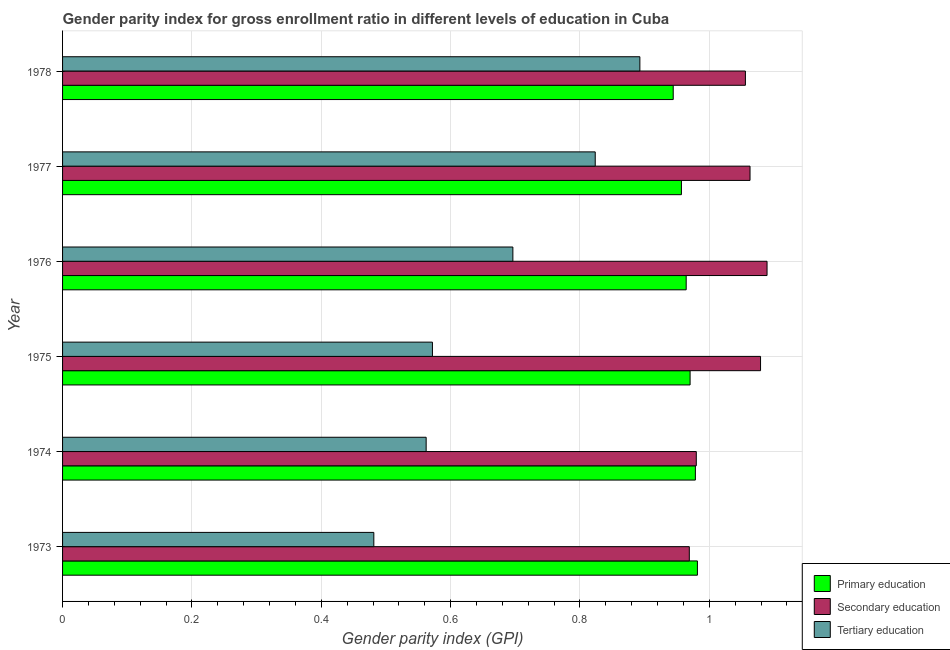How many different coloured bars are there?
Make the answer very short. 3. How many bars are there on the 2nd tick from the top?
Provide a succinct answer. 3. What is the label of the 1st group of bars from the top?
Give a very brief answer. 1978. In how many cases, is the number of bars for a given year not equal to the number of legend labels?
Keep it short and to the point. 0. What is the gender parity index in tertiary education in 1976?
Ensure brevity in your answer.  0.7. Across all years, what is the maximum gender parity index in primary education?
Provide a short and direct response. 0.98. Across all years, what is the minimum gender parity index in primary education?
Give a very brief answer. 0.94. In which year was the gender parity index in tertiary education maximum?
Your answer should be compact. 1978. In which year was the gender parity index in primary education minimum?
Provide a short and direct response. 1978. What is the total gender parity index in primary education in the graph?
Provide a succinct answer. 5.8. What is the difference between the gender parity index in primary education in 1973 and that in 1975?
Provide a succinct answer. 0.01. What is the difference between the gender parity index in primary education in 1976 and the gender parity index in tertiary education in 1973?
Your answer should be compact. 0.48. What is the average gender parity index in secondary education per year?
Offer a terse response. 1.04. In the year 1977, what is the difference between the gender parity index in secondary education and gender parity index in primary education?
Keep it short and to the point. 0.11. What is the ratio of the gender parity index in tertiary education in 1973 to that in 1975?
Ensure brevity in your answer.  0.84. Is the difference between the gender parity index in primary education in 1973 and 1974 greater than the difference between the gender parity index in secondary education in 1973 and 1974?
Ensure brevity in your answer.  Yes. What is the difference between the highest and the second highest gender parity index in primary education?
Offer a terse response. 0. What is the difference between the highest and the lowest gender parity index in secondary education?
Make the answer very short. 0.12. What does the 3rd bar from the bottom in 1975 represents?
Your answer should be very brief. Tertiary education. Is it the case that in every year, the sum of the gender parity index in primary education and gender parity index in secondary education is greater than the gender parity index in tertiary education?
Your answer should be very brief. Yes. Are all the bars in the graph horizontal?
Offer a very short reply. Yes. What is the difference between two consecutive major ticks on the X-axis?
Your response must be concise. 0.2. Are the values on the major ticks of X-axis written in scientific E-notation?
Ensure brevity in your answer.  No. Where does the legend appear in the graph?
Ensure brevity in your answer.  Bottom right. What is the title of the graph?
Ensure brevity in your answer.  Gender parity index for gross enrollment ratio in different levels of education in Cuba. Does "Nuclear sources" appear as one of the legend labels in the graph?
Make the answer very short. No. What is the label or title of the X-axis?
Give a very brief answer. Gender parity index (GPI). What is the Gender parity index (GPI) in Primary education in 1973?
Your answer should be very brief. 0.98. What is the Gender parity index (GPI) in Secondary education in 1973?
Provide a short and direct response. 0.97. What is the Gender parity index (GPI) in Tertiary education in 1973?
Your answer should be compact. 0.48. What is the Gender parity index (GPI) of Primary education in 1974?
Your answer should be very brief. 0.98. What is the Gender parity index (GPI) in Secondary education in 1974?
Keep it short and to the point. 0.98. What is the Gender parity index (GPI) of Tertiary education in 1974?
Make the answer very short. 0.56. What is the Gender parity index (GPI) of Primary education in 1975?
Ensure brevity in your answer.  0.97. What is the Gender parity index (GPI) of Secondary education in 1975?
Provide a succinct answer. 1.08. What is the Gender parity index (GPI) in Tertiary education in 1975?
Provide a succinct answer. 0.57. What is the Gender parity index (GPI) in Primary education in 1976?
Offer a terse response. 0.96. What is the Gender parity index (GPI) of Secondary education in 1976?
Provide a succinct answer. 1.09. What is the Gender parity index (GPI) of Tertiary education in 1976?
Give a very brief answer. 0.7. What is the Gender parity index (GPI) of Primary education in 1977?
Offer a very short reply. 0.96. What is the Gender parity index (GPI) in Secondary education in 1977?
Make the answer very short. 1.06. What is the Gender parity index (GPI) in Tertiary education in 1977?
Provide a succinct answer. 0.82. What is the Gender parity index (GPI) in Primary education in 1978?
Your answer should be compact. 0.94. What is the Gender parity index (GPI) of Secondary education in 1978?
Provide a succinct answer. 1.06. What is the Gender parity index (GPI) in Tertiary education in 1978?
Your response must be concise. 0.89. Across all years, what is the maximum Gender parity index (GPI) of Primary education?
Your answer should be compact. 0.98. Across all years, what is the maximum Gender parity index (GPI) in Secondary education?
Provide a succinct answer. 1.09. Across all years, what is the maximum Gender parity index (GPI) in Tertiary education?
Ensure brevity in your answer.  0.89. Across all years, what is the minimum Gender parity index (GPI) of Primary education?
Your answer should be very brief. 0.94. Across all years, what is the minimum Gender parity index (GPI) of Secondary education?
Provide a short and direct response. 0.97. Across all years, what is the minimum Gender parity index (GPI) in Tertiary education?
Ensure brevity in your answer.  0.48. What is the total Gender parity index (GPI) in Primary education in the graph?
Your answer should be compact. 5.8. What is the total Gender parity index (GPI) of Secondary education in the graph?
Keep it short and to the point. 6.24. What is the total Gender parity index (GPI) in Tertiary education in the graph?
Keep it short and to the point. 4.03. What is the difference between the Gender parity index (GPI) in Primary education in 1973 and that in 1974?
Ensure brevity in your answer.  0. What is the difference between the Gender parity index (GPI) in Secondary education in 1973 and that in 1974?
Your answer should be compact. -0.01. What is the difference between the Gender parity index (GPI) of Tertiary education in 1973 and that in 1974?
Make the answer very short. -0.08. What is the difference between the Gender parity index (GPI) of Primary education in 1973 and that in 1975?
Your answer should be very brief. 0.01. What is the difference between the Gender parity index (GPI) of Secondary education in 1973 and that in 1975?
Ensure brevity in your answer.  -0.11. What is the difference between the Gender parity index (GPI) of Tertiary education in 1973 and that in 1975?
Ensure brevity in your answer.  -0.09. What is the difference between the Gender parity index (GPI) in Primary education in 1973 and that in 1976?
Offer a terse response. 0.02. What is the difference between the Gender parity index (GPI) in Secondary education in 1973 and that in 1976?
Offer a terse response. -0.12. What is the difference between the Gender parity index (GPI) of Tertiary education in 1973 and that in 1976?
Your answer should be compact. -0.21. What is the difference between the Gender parity index (GPI) in Primary education in 1973 and that in 1977?
Keep it short and to the point. 0.02. What is the difference between the Gender parity index (GPI) of Secondary education in 1973 and that in 1977?
Ensure brevity in your answer.  -0.09. What is the difference between the Gender parity index (GPI) in Tertiary education in 1973 and that in 1977?
Provide a short and direct response. -0.34. What is the difference between the Gender parity index (GPI) of Primary education in 1973 and that in 1978?
Keep it short and to the point. 0.04. What is the difference between the Gender parity index (GPI) of Secondary education in 1973 and that in 1978?
Keep it short and to the point. -0.09. What is the difference between the Gender parity index (GPI) of Tertiary education in 1973 and that in 1978?
Provide a succinct answer. -0.41. What is the difference between the Gender parity index (GPI) in Primary education in 1974 and that in 1975?
Your answer should be compact. 0.01. What is the difference between the Gender parity index (GPI) of Secondary education in 1974 and that in 1975?
Make the answer very short. -0.1. What is the difference between the Gender parity index (GPI) in Tertiary education in 1974 and that in 1975?
Keep it short and to the point. -0.01. What is the difference between the Gender parity index (GPI) of Primary education in 1974 and that in 1976?
Your answer should be very brief. 0.01. What is the difference between the Gender parity index (GPI) in Secondary education in 1974 and that in 1976?
Offer a terse response. -0.11. What is the difference between the Gender parity index (GPI) in Tertiary education in 1974 and that in 1976?
Your response must be concise. -0.13. What is the difference between the Gender parity index (GPI) of Primary education in 1974 and that in 1977?
Give a very brief answer. 0.02. What is the difference between the Gender parity index (GPI) of Secondary education in 1974 and that in 1977?
Keep it short and to the point. -0.08. What is the difference between the Gender parity index (GPI) of Tertiary education in 1974 and that in 1977?
Offer a terse response. -0.26. What is the difference between the Gender parity index (GPI) in Primary education in 1974 and that in 1978?
Give a very brief answer. 0.03. What is the difference between the Gender parity index (GPI) of Secondary education in 1974 and that in 1978?
Provide a short and direct response. -0.08. What is the difference between the Gender parity index (GPI) of Tertiary education in 1974 and that in 1978?
Ensure brevity in your answer.  -0.33. What is the difference between the Gender parity index (GPI) in Primary education in 1975 and that in 1976?
Ensure brevity in your answer.  0.01. What is the difference between the Gender parity index (GPI) in Secondary education in 1975 and that in 1976?
Provide a succinct answer. -0.01. What is the difference between the Gender parity index (GPI) in Tertiary education in 1975 and that in 1976?
Your answer should be compact. -0.12. What is the difference between the Gender parity index (GPI) of Primary education in 1975 and that in 1977?
Provide a succinct answer. 0.01. What is the difference between the Gender parity index (GPI) of Secondary education in 1975 and that in 1977?
Provide a succinct answer. 0.02. What is the difference between the Gender parity index (GPI) of Tertiary education in 1975 and that in 1977?
Your answer should be very brief. -0.25. What is the difference between the Gender parity index (GPI) of Primary education in 1975 and that in 1978?
Your response must be concise. 0.03. What is the difference between the Gender parity index (GPI) of Secondary education in 1975 and that in 1978?
Your answer should be very brief. 0.02. What is the difference between the Gender parity index (GPI) in Tertiary education in 1975 and that in 1978?
Provide a short and direct response. -0.32. What is the difference between the Gender parity index (GPI) of Primary education in 1976 and that in 1977?
Provide a succinct answer. 0.01. What is the difference between the Gender parity index (GPI) of Secondary education in 1976 and that in 1977?
Give a very brief answer. 0.03. What is the difference between the Gender parity index (GPI) of Tertiary education in 1976 and that in 1977?
Make the answer very short. -0.13. What is the difference between the Gender parity index (GPI) of Primary education in 1976 and that in 1978?
Offer a terse response. 0.02. What is the difference between the Gender parity index (GPI) in Secondary education in 1976 and that in 1978?
Give a very brief answer. 0.03. What is the difference between the Gender parity index (GPI) of Tertiary education in 1976 and that in 1978?
Provide a succinct answer. -0.2. What is the difference between the Gender parity index (GPI) of Primary education in 1977 and that in 1978?
Provide a succinct answer. 0.01. What is the difference between the Gender parity index (GPI) in Secondary education in 1977 and that in 1978?
Ensure brevity in your answer.  0.01. What is the difference between the Gender parity index (GPI) in Tertiary education in 1977 and that in 1978?
Provide a short and direct response. -0.07. What is the difference between the Gender parity index (GPI) of Primary education in 1973 and the Gender parity index (GPI) of Secondary education in 1974?
Keep it short and to the point. 0. What is the difference between the Gender parity index (GPI) of Primary education in 1973 and the Gender parity index (GPI) of Tertiary education in 1974?
Keep it short and to the point. 0.42. What is the difference between the Gender parity index (GPI) in Secondary education in 1973 and the Gender parity index (GPI) in Tertiary education in 1974?
Your answer should be compact. 0.41. What is the difference between the Gender parity index (GPI) of Primary education in 1973 and the Gender parity index (GPI) of Secondary education in 1975?
Provide a succinct answer. -0.1. What is the difference between the Gender parity index (GPI) of Primary education in 1973 and the Gender parity index (GPI) of Tertiary education in 1975?
Your response must be concise. 0.41. What is the difference between the Gender parity index (GPI) in Secondary education in 1973 and the Gender parity index (GPI) in Tertiary education in 1975?
Ensure brevity in your answer.  0.4. What is the difference between the Gender parity index (GPI) in Primary education in 1973 and the Gender parity index (GPI) in Secondary education in 1976?
Keep it short and to the point. -0.11. What is the difference between the Gender parity index (GPI) of Primary education in 1973 and the Gender parity index (GPI) of Tertiary education in 1976?
Keep it short and to the point. 0.29. What is the difference between the Gender parity index (GPI) of Secondary education in 1973 and the Gender parity index (GPI) of Tertiary education in 1976?
Keep it short and to the point. 0.27. What is the difference between the Gender parity index (GPI) in Primary education in 1973 and the Gender parity index (GPI) in Secondary education in 1977?
Your response must be concise. -0.08. What is the difference between the Gender parity index (GPI) in Primary education in 1973 and the Gender parity index (GPI) in Tertiary education in 1977?
Provide a short and direct response. 0.16. What is the difference between the Gender parity index (GPI) of Secondary education in 1973 and the Gender parity index (GPI) of Tertiary education in 1977?
Provide a short and direct response. 0.15. What is the difference between the Gender parity index (GPI) in Primary education in 1973 and the Gender parity index (GPI) in Secondary education in 1978?
Your answer should be very brief. -0.07. What is the difference between the Gender parity index (GPI) of Primary education in 1973 and the Gender parity index (GPI) of Tertiary education in 1978?
Keep it short and to the point. 0.09. What is the difference between the Gender parity index (GPI) of Secondary education in 1973 and the Gender parity index (GPI) of Tertiary education in 1978?
Make the answer very short. 0.08. What is the difference between the Gender parity index (GPI) of Primary education in 1974 and the Gender parity index (GPI) of Secondary education in 1975?
Offer a terse response. -0.1. What is the difference between the Gender parity index (GPI) in Primary education in 1974 and the Gender parity index (GPI) in Tertiary education in 1975?
Your answer should be compact. 0.41. What is the difference between the Gender parity index (GPI) in Secondary education in 1974 and the Gender parity index (GPI) in Tertiary education in 1975?
Provide a short and direct response. 0.41. What is the difference between the Gender parity index (GPI) in Primary education in 1974 and the Gender parity index (GPI) in Secondary education in 1976?
Make the answer very short. -0.11. What is the difference between the Gender parity index (GPI) in Primary education in 1974 and the Gender parity index (GPI) in Tertiary education in 1976?
Offer a terse response. 0.28. What is the difference between the Gender parity index (GPI) of Secondary education in 1974 and the Gender parity index (GPI) of Tertiary education in 1976?
Your answer should be compact. 0.28. What is the difference between the Gender parity index (GPI) of Primary education in 1974 and the Gender parity index (GPI) of Secondary education in 1977?
Your answer should be compact. -0.08. What is the difference between the Gender parity index (GPI) in Primary education in 1974 and the Gender parity index (GPI) in Tertiary education in 1977?
Provide a succinct answer. 0.15. What is the difference between the Gender parity index (GPI) in Secondary education in 1974 and the Gender parity index (GPI) in Tertiary education in 1977?
Your response must be concise. 0.16. What is the difference between the Gender parity index (GPI) of Primary education in 1974 and the Gender parity index (GPI) of Secondary education in 1978?
Your response must be concise. -0.08. What is the difference between the Gender parity index (GPI) of Primary education in 1974 and the Gender parity index (GPI) of Tertiary education in 1978?
Provide a short and direct response. 0.09. What is the difference between the Gender parity index (GPI) of Secondary education in 1974 and the Gender parity index (GPI) of Tertiary education in 1978?
Your answer should be very brief. 0.09. What is the difference between the Gender parity index (GPI) of Primary education in 1975 and the Gender parity index (GPI) of Secondary education in 1976?
Provide a succinct answer. -0.12. What is the difference between the Gender parity index (GPI) in Primary education in 1975 and the Gender parity index (GPI) in Tertiary education in 1976?
Provide a short and direct response. 0.27. What is the difference between the Gender parity index (GPI) of Secondary education in 1975 and the Gender parity index (GPI) of Tertiary education in 1976?
Give a very brief answer. 0.38. What is the difference between the Gender parity index (GPI) in Primary education in 1975 and the Gender parity index (GPI) in Secondary education in 1977?
Your answer should be very brief. -0.09. What is the difference between the Gender parity index (GPI) of Primary education in 1975 and the Gender parity index (GPI) of Tertiary education in 1977?
Provide a succinct answer. 0.15. What is the difference between the Gender parity index (GPI) in Secondary education in 1975 and the Gender parity index (GPI) in Tertiary education in 1977?
Keep it short and to the point. 0.26. What is the difference between the Gender parity index (GPI) of Primary education in 1975 and the Gender parity index (GPI) of Secondary education in 1978?
Ensure brevity in your answer.  -0.09. What is the difference between the Gender parity index (GPI) in Primary education in 1975 and the Gender parity index (GPI) in Tertiary education in 1978?
Provide a succinct answer. 0.08. What is the difference between the Gender parity index (GPI) of Secondary education in 1975 and the Gender parity index (GPI) of Tertiary education in 1978?
Your answer should be very brief. 0.19. What is the difference between the Gender parity index (GPI) in Primary education in 1976 and the Gender parity index (GPI) in Secondary education in 1977?
Provide a short and direct response. -0.1. What is the difference between the Gender parity index (GPI) in Primary education in 1976 and the Gender parity index (GPI) in Tertiary education in 1977?
Make the answer very short. 0.14. What is the difference between the Gender parity index (GPI) in Secondary education in 1976 and the Gender parity index (GPI) in Tertiary education in 1977?
Offer a terse response. 0.27. What is the difference between the Gender parity index (GPI) in Primary education in 1976 and the Gender parity index (GPI) in Secondary education in 1978?
Make the answer very short. -0.09. What is the difference between the Gender parity index (GPI) of Primary education in 1976 and the Gender parity index (GPI) of Tertiary education in 1978?
Your response must be concise. 0.07. What is the difference between the Gender parity index (GPI) of Secondary education in 1976 and the Gender parity index (GPI) of Tertiary education in 1978?
Ensure brevity in your answer.  0.2. What is the difference between the Gender parity index (GPI) of Primary education in 1977 and the Gender parity index (GPI) of Secondary education in 1978?
Your answer should be compact. -0.1. What is the difference between the Gender parity index (GPI) of Primary education in 1977 and the Gender parity index (GPI) of Tertiary education in 1978?
Provide a short and direct response. 0.06. What is the difference between the Gender parity index (GPI) in Secondary education in 1977 and the Gender parity index (GPI) in Tertiary education in 1978?
Give a very brief answer. 0.17. What is the average Gender parity index (GPI) in Secondary education per year?
Your answer should be compact. 1.04. What is the average Gender parity index (GPI) in Tertiary education per year?
Give a very brief answer. 0.67. In the year 1973, what is the difference between the Gender parity index (GPI) of Primary education and Gender parity index (GPI) of Secondary education?
Your response must be concise. 0.01. In the year 1973, what is the difference between the Gender parity index (GPI) of Primary education and Gender parity index (GPI) of Tertiary education?
Make the answer very short. 0.5. In the year 1973, what is the difference between the Gender parity index (GPI) in Secondary education and Gender parity index (GPI) in Tertiary education?
Give a very brief answer. 0.49. In the year 1974, what is the difference between the Gender parity index (GPI) of Primary education and Gender parity index (GPI) of Secondary education?
Offer a very short reply. -0. In the year 1974, what is the difference between the Gender parity index (GPI) in Primary education and Gender parity index (GPI) in Tertiary education?
Keep it short and to the point. 0.42. In the year 1974, what is the difference between the Gender parity index (GPI) in Secondary education and Gender parity index (GPI) in Tertiary education?
Your response must be concise. 0.42. In the year 1975, what is the difference between the Gender parity index (GPI) in Primary education and Gender parity index (GPI) in Secondary education?
Provide a short and direct response. -0.11. In the year 1975, what is the difference between the Gender parity index (GPI) of Primary education and Gender parity index (GPI) of Tertiary education?
Ensure brevity in your answer.  0.4. In the year 1975, what is the difference between the Gender parity index (GPI) of Secondary education and Gender parity index (GPI) of Tertiary education?
Give a very brief answer. 0.51. In the year 1976, what is the difference between the Gender parity index (GPI) of Primary education and Gender parity index (GPI) of Secondary education?
Make the answer very short. -0.12. In the year 1976, what is the difference between the Gender parity index (GPI) in Primary education and Gender parity index (GPI) in Tertiary education?
Offer a very short reply. 0.27. In the year 1976, what is the difference between the Gender parity index (GPI) in Secondary education and Gender parity index (GPI) in Tertiary education?
Provide a short and direct response. 0.39. In the year 1977, what is the difference between the Gender parity index (GPI) in Primary education and Gender parity index (GPI) in Secondary education?
Give a very brief answer. -0.11. In the year 1977, what is the difference between the Gender parity index (GPI) of Primary education and Gender parity index (GPI) of Tertiary education?
Your answer should be compact. 0.13. In the year 1977, what is the difference between the Gender parity index (GPI) of Secondary education and Gender parity index (GPI) of Tertiary education?
Offer a very short reply. 0.24. In the year 1978, what is the difference between the Gender parity index (GPI) in Primary education and Gender parity index (GPI) in Secondary education?
Your response must be concise. -0.11. In the year 1978, what is the difference between the Gender parity index (GPI) of Primary education and Gender parity index (GPI) of Tertiary education?
Ensure brevity in your answer.  0.05. In the year 1978, what is the difference between the Gender parity index (GPI) in Secondary education and Gender parity index (GPI) in Tertiary education?
Provide a succinct answer. 0.16. What is the ratio of the Gender parity index (GPI) in Primary education in 1973 to that in 1974?
Give a very brief answer. 1. What is the ratio of the Gender parity index (GPI) in Secondary education in 1973 to that in 1974?
Provide a succinct answer. 0.99. What is the ratio of the Gender parity index (GPI) of Tertiary education in 1973 to that in 1974?
Ensure brevity in your answer.  0.86. What is the ratio of the Gender parity index (GPI) of Primary education in 1973 to that in 1975?
Ensure brevity in your answer.  1.01. What is the ratio of the Gender parity index (GPI) of Secondary education in 1973 to that in 1975?
Provide a short and direct response. 0.9. What is the ratio of the Gender parity index (GPI) in Tertiary education in 1973 to that in 1975?
Your response must be concise. 0.84. What is the ratio of the Gender parity index (GPI) in Primary education in 1973 to that in 1976?
Your answer should be very brief. 1.02. What is the ratio of the Gender parity index (GPI) of Secondary education in 1973 to that in 1976?
Your answer should be very brief. 0.89. What is the ratio of the Gender parity index (GPI) of Tertiary education in 1973 to that in 1976?
Ensure brevity in your answer.  0.69. What is the ratio of the Gender parity index (GPI) in Primary education in 1973 to that in 1977?
Your answer should be very brief. 1.03. What is the ratio of the Gender parity index (GPI) in Secondary education in 1973 to that in 1977?
Provide a short and direct response. 0.91. What is the ratio of the Gender parity index (GPI) of Tertiary education in 1973 to that in 1977?
Your answer should be compact. 0.58. What is the ratio of the Gender parity index (GPI) in Primary education in 1973 to that in 1978?
Keep it short and to the point. 1.04. What is the ratio of the Gender parity index (GPI) in Secondary education in 1973 to that in 1978?
Offer a terse response. 0.92. What is the ratio of the Gender parity index (GPI) of Tertiary education in 1973 to that in 1978?
Your answer should be very brief. 0.54. What is the ratio of the Gender parity index (GPI) of Primary education in 1974 to that in 1975?
Make the answer very short. 1.01. What is the ratio of the Gender parity index (GPI) in Secondary education in 1974 to that in 1975?
Give a very brief answer. 0.91. What is the ratio of the Gender parity index (GPI) of Tertiary education in 1974 to that in 1975?
Ensure brevity in your answer.  0.98. What is the ratio of the Gender parity index (GPI) of Primary education in 1974 to that in 1976?
Your answer should be compact. 1.01. What is the ratio of the Gender parity index (GPI) in Secondary education in 1974 to that in 1976?
Ensure brevity in your answer.  0.9. What is the ratio of the Gender parity index (GPI) of Tertiary education in 1974 to that in 1976?
Provide a short and direct response. 0.81. What is the ratio of the Gender parity index (GPI) in Primary education in 1974 to that in 1977?
Offer a very short reply. 1.02. What is the ratio of the Gender parity index (GPI) of Secondary education in 1974 to that in 1977?
Provide a succinct answer. 0.92. What is the ratio of the Gender parity index (GPI) in Tertiary education in 1974 to that in 1977?
Give a very brief answer. 0.68. What is the ratio of the Gender parity index (GPI) in Primary education in 1974 to that in 1978?
Your response must be concise. 1.04. What is the ratio of the Gender parity index (GPI) of Secondary education in 1974 to that in 1978?
Give a very brief answer. 0.93. What is the ratio of the Gender parity index (GPI) of Tertiary education in 1974 to that in 1978?
Provide a succinct answer. 0.63. What is the ratio of the Gender parity index (GPI) in Tertiary education in 1975 to that in 1976?
Offer a very short reply. 0.82. What is the ratio of the Gender parity index (GPI) of Primary education in 1975 to that in 1977?
Ensure brevity in your answer.  1.01. What is the ratio of the Gender parity index (GPI) in Secondary education in 1975 to that in 1977?
Provide a succinct answer. 1.02. What is the ratio of the Gender parity index (GPI) of Tertiary education in 1975 to that in 1977?
Offer a very short reply. 0.69. What is the ratio of the Gender parity index (GPI) of Primary education in 1975 to that in 1978?
Give a very brief answer. 1.03. What is the ratio of the Gender parity index (GPI) in Secondary education in 1975 to that in 1978?
Your response must be concise. 1.02. What is the ratio of the Gender parity index (GPI) in Tertiary education in 1975 to that in 1978?
Keep it short and to the point. 0.64. What is the ratio of the Gender parity index (GPI) of Primary education in 1976 to that in 1977?
Ensure brevity in your answer.  1.01. What is the ratio of the Gender parity index (GPI) of Secondary education in 1976 to that in 1977?
Provide a succinct answer. 1.02. What is the ratio of the Gender parity index (GPI) in Tertiary education in 1976 to that in 1977?
Provide a succinct answer. 0.85. What is the ratio of the Gender parity index (GPI) of Primary education in 1976 to that in 1978?
Provide a succinct answer. 1.02. What is the ratio of the Gender parity index (GPI) of Secondary education in 1976 to that in 1978?
Your answer should be compact. 1.03. What is the ratio of the Gender parity index (GPI) in Tertiary education in 1976 to that in 1978?
Keep it short and to the point. 0.78. What is the ratio of the Gender parity index (GPI) in Primary education in 1977 to that in 1978?
Provide a succinct answer. 1.01. What is the ratio of the Gender parity index (GPI) of Secondary education in 1977 to that in 1978?
Your answer should be compact. 1.01. What is the ratio of the Gender parity index (GPI) in Tertiary education in 1977 to that in 1978?
Keep it short and to the point. 0.92. What is the difference between the highest and the second highest Gender parity index (GPI) of Primary education?
Provide a short and direct response. 0. What is the difference between the highest and the second highest Gender parity index (GPI) in Secondary education?
Ensure brevity in your answer.  0.01. What is the difference between the highest and the second highest Gender parity index (GPI) in Tertiary education?
Give a very brief answer. 0.07. What is the difference between the highest and the lowest Gender parity index (GPI) in Primary education?
Your answer should be very brief. 0.04. What is the difference between the highest and the lowest Gender parity index (GPI) of Secondary education?
Give a very brief answer. 0.12. What is the difference between the highest and the lowest Gender parity index (GPI) in Tertiary education?
Keep it short and to the point. 0.41. 